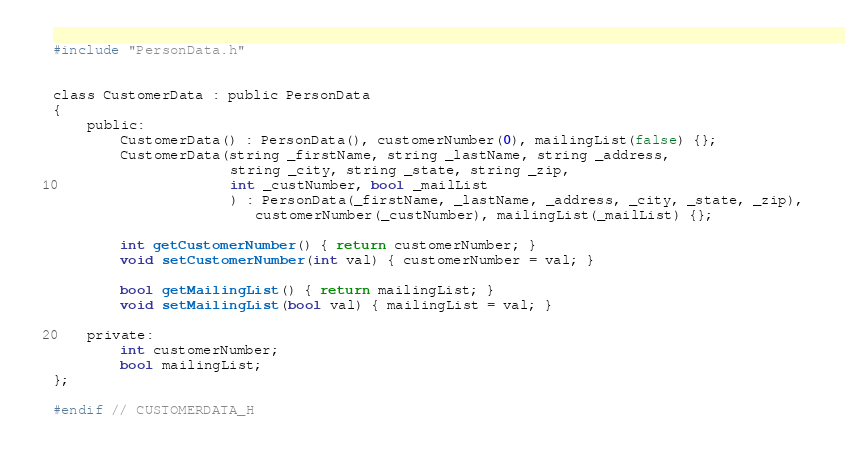<code> <loc_0><loc_0><loc_500><loc_500><_C_>#include "PersonData.h"


class CustomerData : public PersonData
{
    public:
        CustomerData() : PersonData(), customerNumber(0), mailingList(false) {};
        CustomerData(string _firstName, string _lastName, string _address,
                     string _city, string _state, string _zip,
                     int _custNumber, bool _mailList
                     ) : PersonData(_firstName, _lastName, _address, _city, _state, _zip),
                        customerNumber(_custNumber), mailingList(_mailList) {};

        int getCustomerNumber() { return customerNumber; }
        void setCustomerNumber(int val) { customerNumber = val; }

        bool getMailingList() { return mailingList; }
        void setMailingList(bool val) { mailingList = val; }

    private:
        int customerNumber;
        bool mailingList;
};

#endif // CUSTOMERDATA_H
</code> 